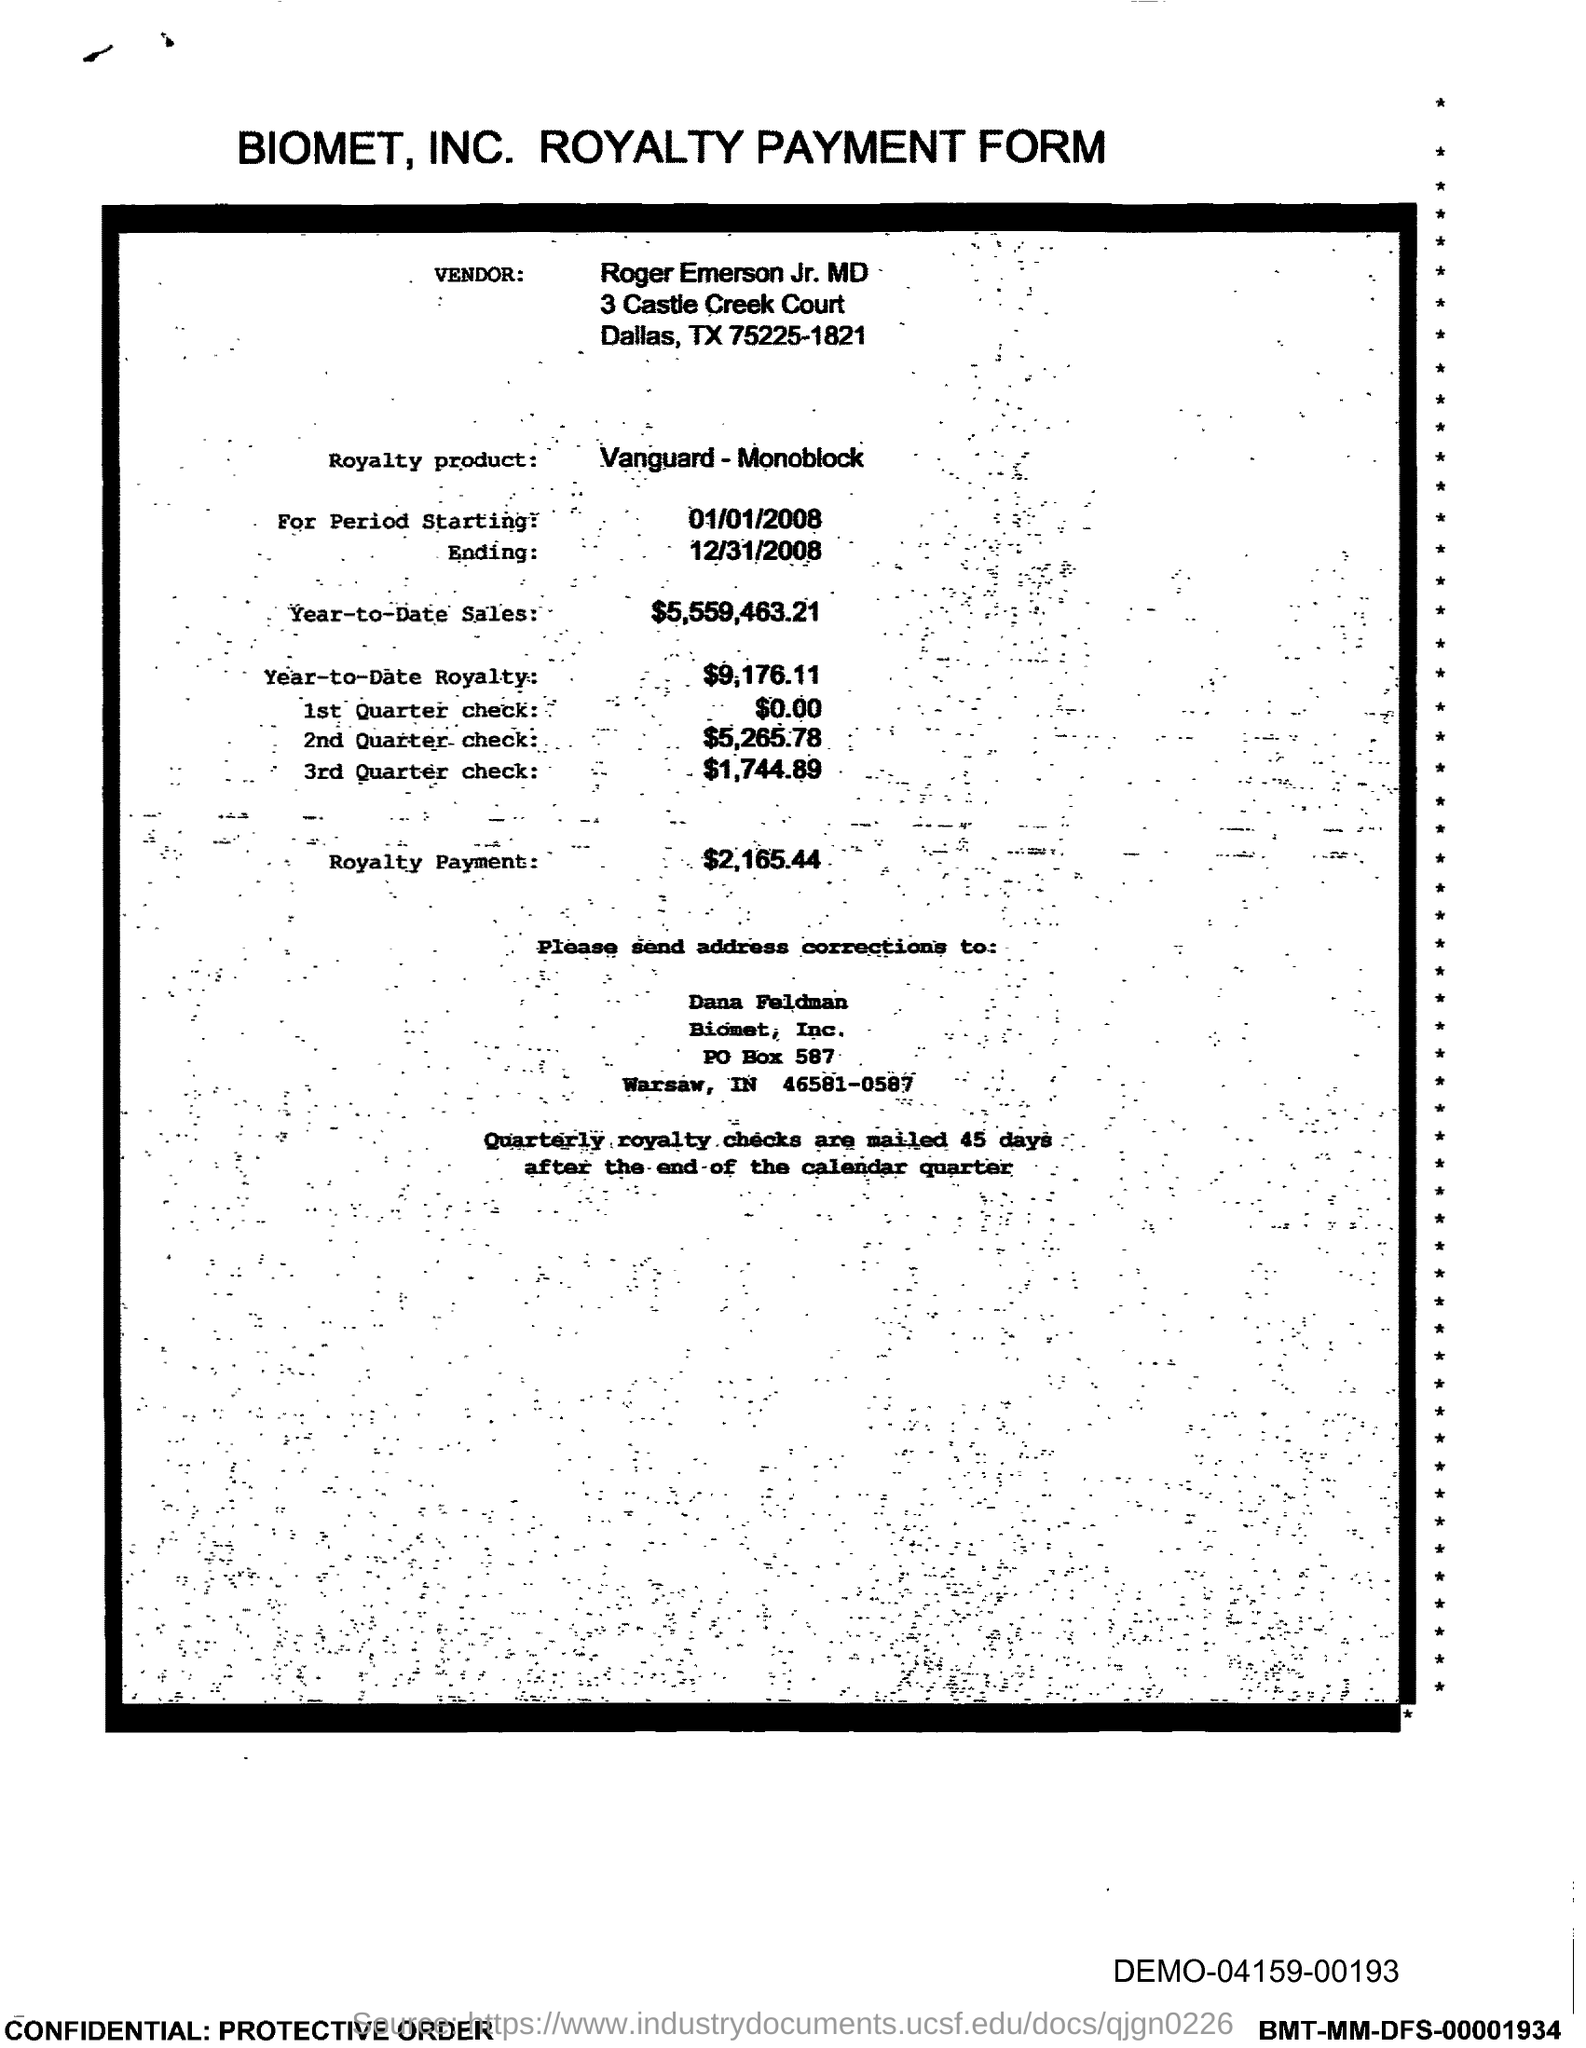Give some essential details in this illustration. The royalty payment is $2,165.44. The PO box number of Biomet, Inc. is 587. Biomet, Inc. is located in the state of Indiana. The royalty earnings for the current year up until now are $9,176.11. The year-to-date sales as of today are $5,559,463.21. 